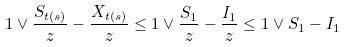<formula> <loc_0><loc_0><loc_500><loc_500>1 \vee \frac { S _ { t ( s ) } } { z } - \frac { X _ { t ( s ) } } { z } \leq 1 \vee \frac { S _ { 1 } } { z } - \frac { I _ { 1 } } { z } \leq 1 \vee S _ { 1 } - I _ { 1 }</formula> 